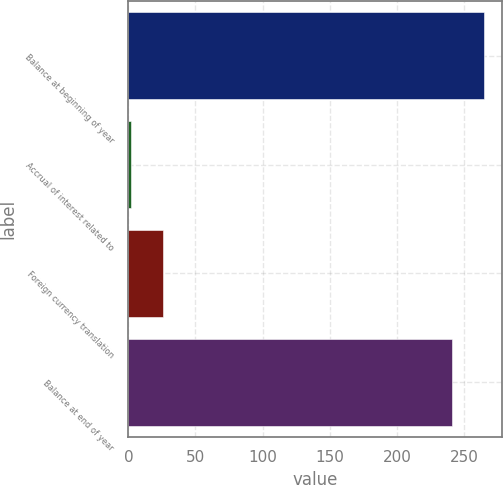<chart> <loc_0><loc_0><loc_500><loc_500><bar_chart><fcel>Balance at beginning of year<fcel>Accrual of interest related to<fcel>Foreign currency translation<fcel>Balance at end of year<nl><fcel>265.1<fcel>2<fcel>26.1<fcel>241<nl></chart> 